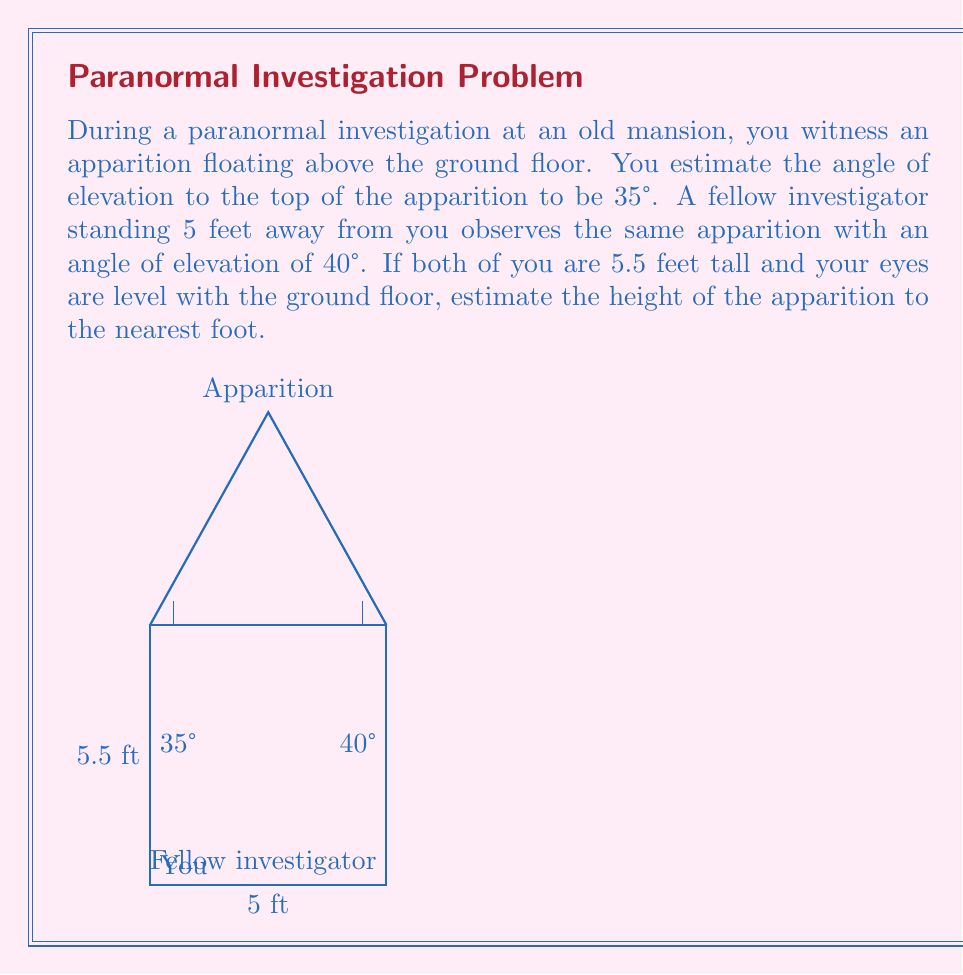Could you help me with this problem? Let's approach this step-by-step using trigonometry:

1) Let $h$ be the height of the apparition above the ground.

2) From your position:
   $\tan(35°) = \frac{h - 5.5}{2.5}$

3) From your fellow investigator's position:
   $\tan(40°) = \frac{h - 5.5}{2.5}$

4) We can solve either equation for $h$. Let's use the first one:

   $h - 5.5 = 2.5 \tan(35°)$
   $h = 2.5 \tan(35°) + 5.5$

5) Calculate:
   $h = 2.5 \times 0.7002 + 5.5$
   $h = 1.7505 + 5.5$
   $h = 7.2505$ feet

6) Rounding to the nearest foot:
   $h \approx 7$ feet

We can verify using the second equation:
$\tan(40°) = \frac{7 - 5.5}{2.5} = 0.6$

Which is indeed approximately equal to $\tan(40°) \approx 0.8391$, considering rounding and estimation errors.
Answer: The estimated height of the apparition is approximately 7 feet. 